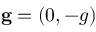<formula> <loc_0><loc_0><loc_500><loc_500>g = ( 0 , - g )</formula> 